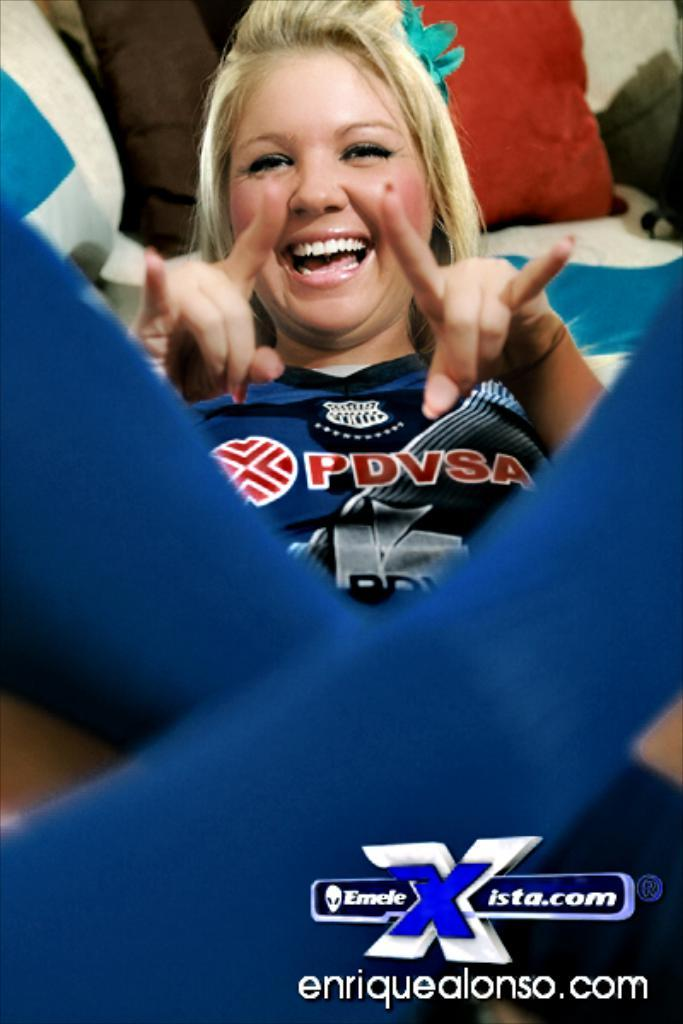<image>
Present a compact description of the photo's key features. a lady with a shirt on that says PDVSA on it 